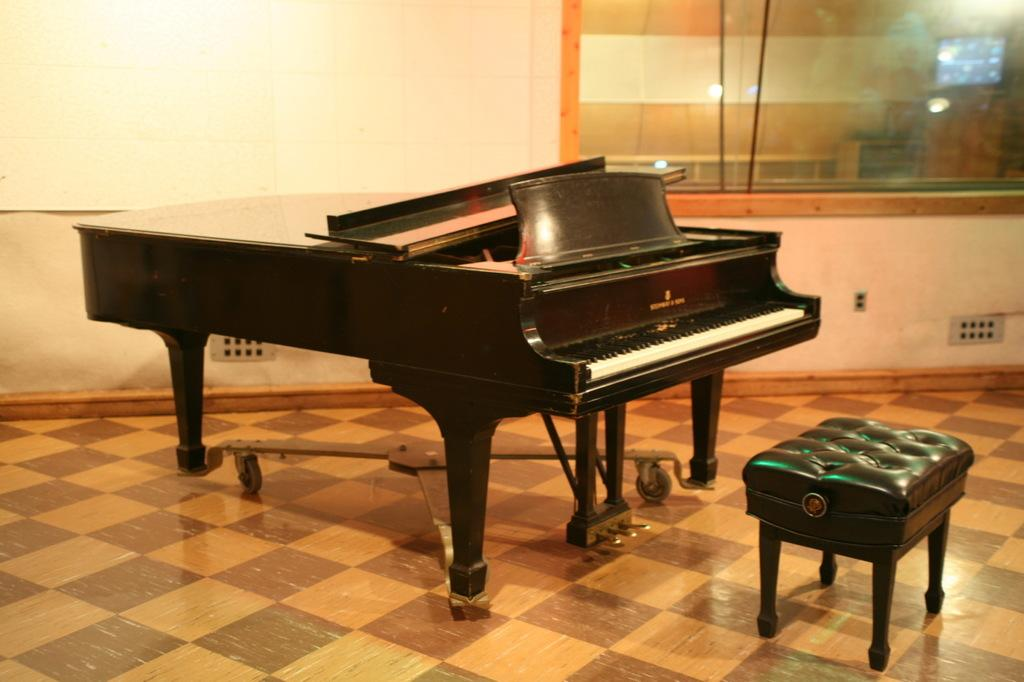What type of musical instrument is in the image? There is a black color piano in the image. What is placed in front of the piano? There is a stool in front of the piano. What type of current can be seen flowing through the piano in the image? There is no current visible in the image; it is a piano and a stool. Can you see the grandfather of the pianist in the image? There is no person present in the image, so it is not possible to see the pianist's grandfather. 